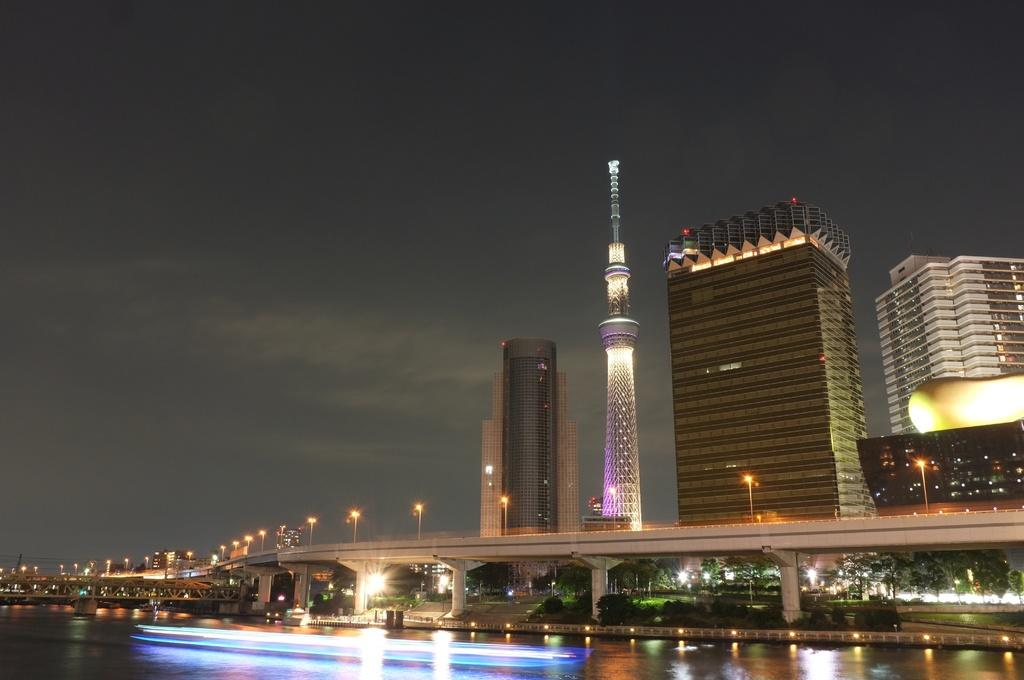What is the main structure visible in the image? There is a flyover in the image. What can be seen behind the flyover? Behind the flyover, there is a tower and buildings. What is located in front of the flyover? In front of the flyover, there is a water pond. What type of creature can be seen swimming in the water pond in the image? There is no creature visible in the water pond in the image. 